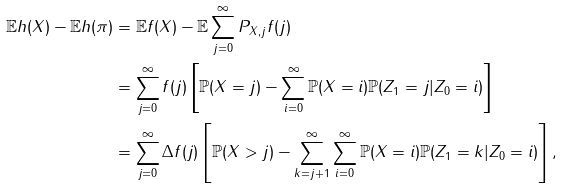Convert formula to latex. <formula><loc_0><loc_0><loc_500><loc_500>\mathbb { E } h ( X ) - \mathbb { E } h ( \pi ) & = \mathbb { E } f ( X ) - \mathbb { E } \sum _ { j = 0 } ^ { \infty } P _ { X , j } f ( j ) \\ & = \sum _ { j = 0 } ^ { \infty } f ( j ) \left [ \mathbb { P } ( X = j ) - \sum _ { i = 0 } ^ { \infty } \mathbb { P } ( X = i ) \mathbb { P } ( Z _ { 1 } = j | Z _ { 0 } = i ) \right ] \\ & = \sum _ { j = 0 } ^ { \infty } \Delta f ( j ) \left [ \mathbb { P } ( X > j ) - \sum _ { k = j + 1 } ^ { \infty } \sum _ { i = 0 } ^ { \infty } \mathbb { P } ( X = i ) \mathbb { P } ( Z _ { 1 } = k | Z _ { 0 } = i ) \right ] ,</formula> 